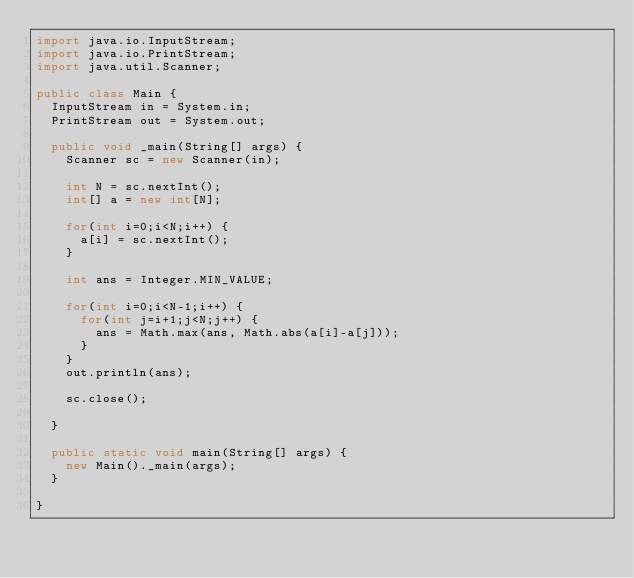<code> <loc_0><loc_0><loc_500><loc_500><_Java_>import java.io.InputStream;
import java.io.PrintStream;
import java.util.Scanner;

public class Main {
	InputStream in = System.in;
	PrintStream out = System.out;

	public void _main(String[] args) {
		Scanner sc = new Scanner(in);

		int N = sc.nextInt();
		int[] a = new int[N];
		
		for(int i=0;i<N;i++) {
			a[i] = sc.nextInt();
		}
		
		int ans = Integer.MIN_VALUE;
		
		for(int i=0;i<N-1;i++) {
			for(int j=i+1;j<N;j++) {
				ans = Math.max(ans, Math.abs(a[i]-a[j]));
			}
		}
		out.println(ans);
		
		sc.close();

	}

	public static void main(String[] args) {
		new Main()._main(args);
	}

}
</code> 